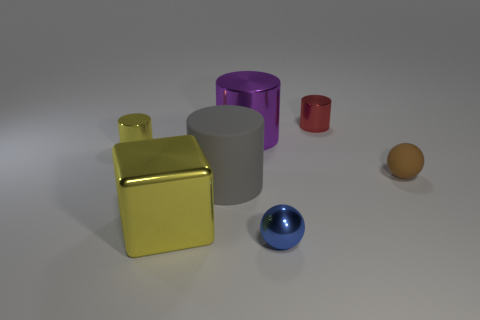The tiny object behind the cylinder on the left side of the matte cylinder is made of what material?
Make the answer very short. Metal. The small red object has what shape?
Keep it short and to the point. Cylinder. Is the number of blue balls that are in front of the tiny brown sphere the same as the number of large gray rubber things that are to the right of the blue sphere?
Give a very brief answer. No. Is the color of the tiny object on the left side of the yellow block the same as the small object that is behind the big purple shiny object?
Your answer should be compact. No. Are there more big shiny things behind the yellow shiny cylinder than matte cylinders?
Provide a short and direct response. No. There is a blue thing that is the same material as the large purple thing; what is its shape?
Provide a succinct answer. Sphere. Does the ball behind the yellow block have the same size as the yellow cylinder?
Provide a short and direct response. Yes. There is a tiny yellow metal object that is behind the small ball that is in front of the big yellow object; what is its shape?
Your answer should be compact. Cylinder. What size is the ball left of the tiny cylinder to the right of the purple metallic object?
Offer a very short reply. Small. There is a matte thing that is on the left side of the matte ball; what color is it?
Give a very brief answer. Gray. 